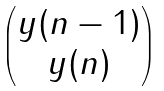Convert formula to latex. <formula><loc_0><loc_0><loc_500><loc_500>\begin{pmatrix} y ( n - 1 ) \\ y ( n ) \end{pmatrix}</formula> 